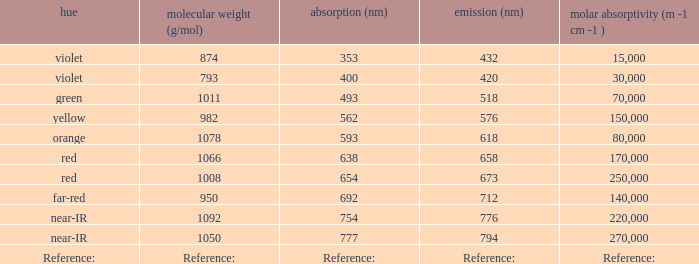What is the Absorbtion (in nanometers) of the color Orange? 593.0. 